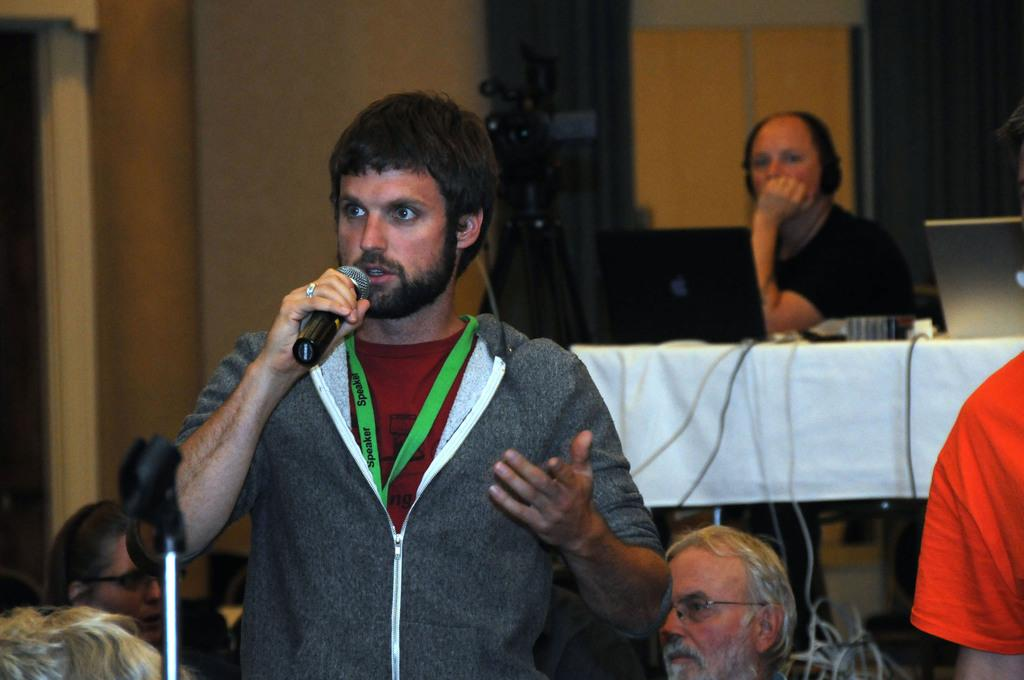What is the man in the image holding? The man is holding a microphone in the image. What is the person sitting doing in the image? The person sitting has their hand on a table in the image. Can you describe the appearance of the person sitting? The person sitting is wearing glasses. What can be seen in the background of the image? There is a camera and a wall visible in the background of the image. What type of kitty is sitting on the table next to the person in the image? There is no kitty present in the image; only the man holding a microphone and the person sitting are visible. 